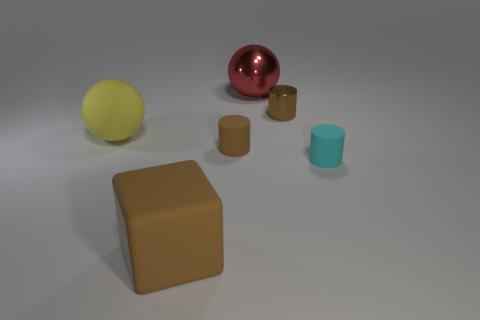There is a cylinder that is on the left side of the tiny brown metal object; is its color the same as the big rubber block?
Provide a short and direct response. Yes. What number of other things are the same color as the rubber block?
Your response must be concise. 2. What is the size of the shiny cylinder that is the same color as the cube?
Your answer should be compact. Small. Does the small brown cylinder that is in front of the yellow matte ball have the same material as the yellow thing?
Keep it short and to the point. Yes. Is there a tiny rubber cylinder of the same color as the big rubber cube?
Provide a succinct answer. Yes. There is a small cyan matte thing that is in front of the metallic sphere; does it have the same shape as the tiny object left of the red metallic thing?
Give a very brief answer. Yes. Are there any yellow balls that have the same material as the cyan thing?
Give a very brief answer. Yes. How many gray objects are small things or large metal objects?
Keep it short and to the point. 0. There is a rubber object that is in front of the brown rubber cylinder and to the left of the red sphere; how big is it?
Your answer should be compact. Large. Are there more brown metal cylinders behind the large matte sphere than tiny red things?
Provide a short and direct response. Yes. 